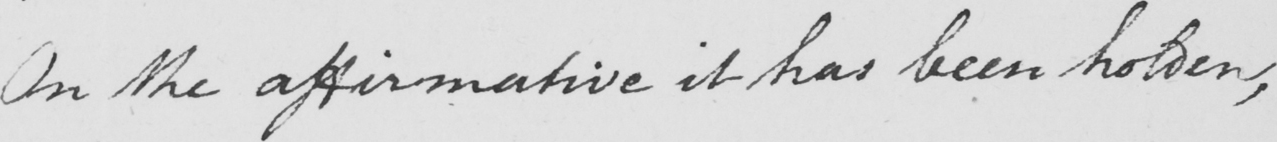What text is written in this handwritten line? On the affirmative it has been holden , 